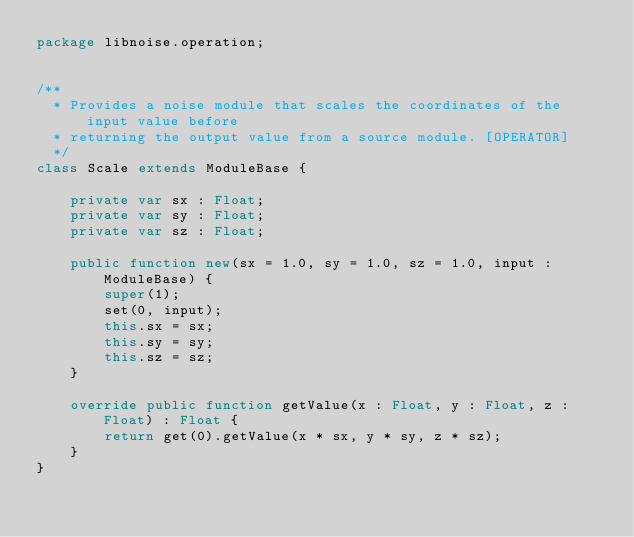<code> <loc_0><loc_0><loc_500><loc_500><_Haxe_>package libnoise.operation;


/**
  * Provides a noise module that scales the coordinates of the input value before
  * returning the output value from a source module. [OPERATOR]
  */
class Scale extends ModuleBase {

	private var sx : Float;
	private var sy : Float;
	private var sz : Float;

	public function new(sx = 1.0, sy = 1.0, sz = 1.0, input : ModuleBase) {
		super(1);
		set(0, input);
		this.sx = sx;
		this.sy = sy;
		this.sz = sz;
	}

	override public function getValue(x : Float, y : Float, z : Float) : Float {
		return get(0).getValue(x * sx, y * sy, z * sz);
	}
}
</code> 